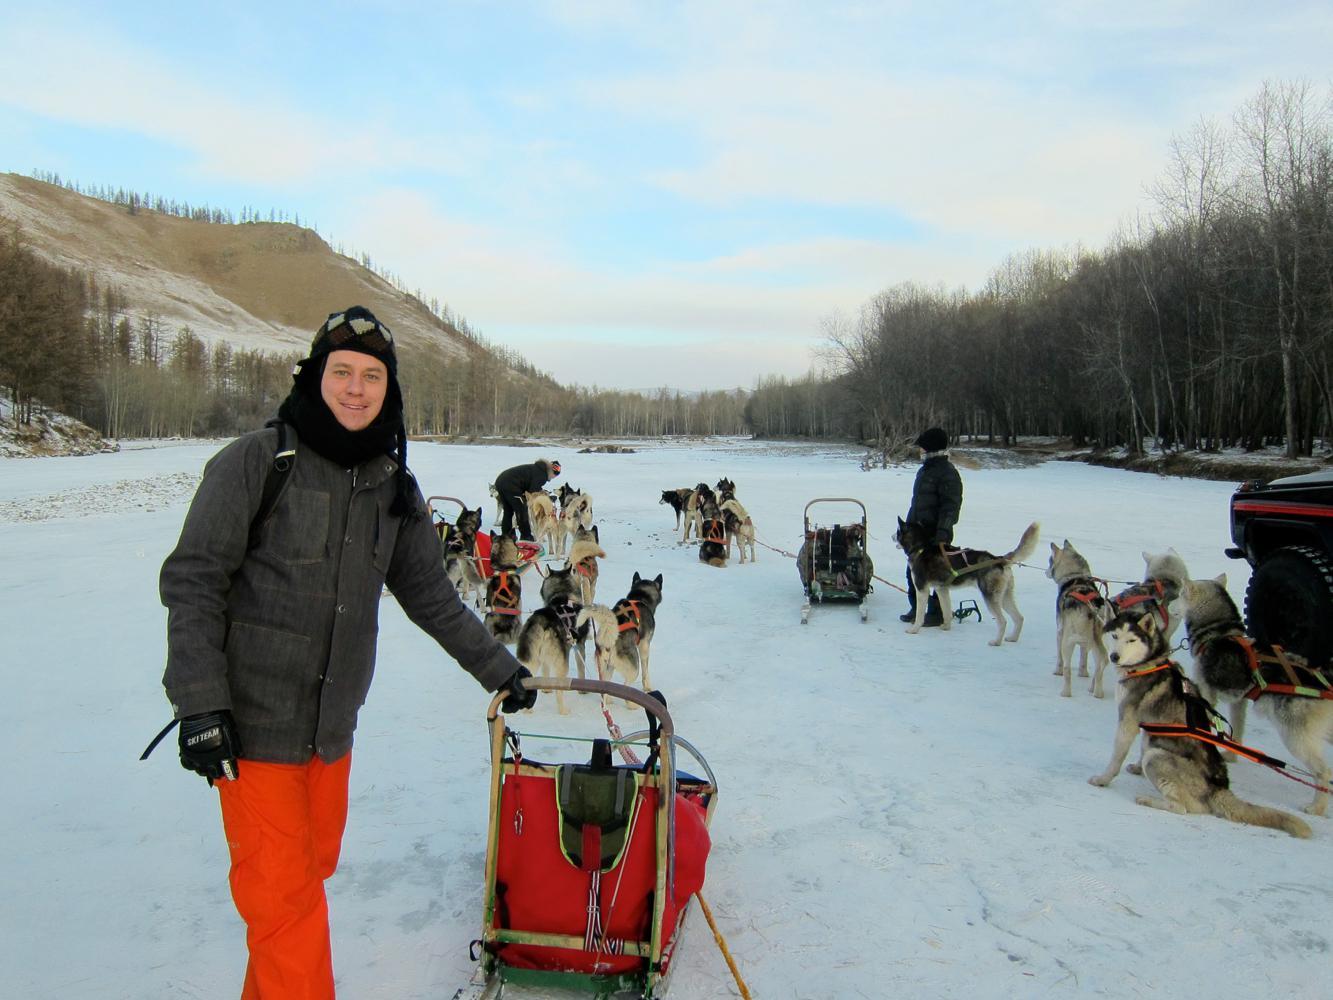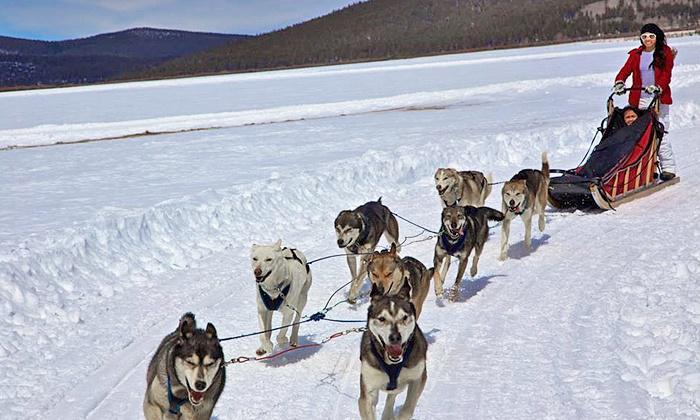The first image is the image on the left, the second image is the image on the right. For the images shown, is this caption "There is at least one human pictured." true? Answer yes or no. Yes. The first image is the image on the left, the second image is the image on the right. For the images displayed, is the sentence "The sled is red in the image on the left" factually correct? Answer yes or no. Yes. 